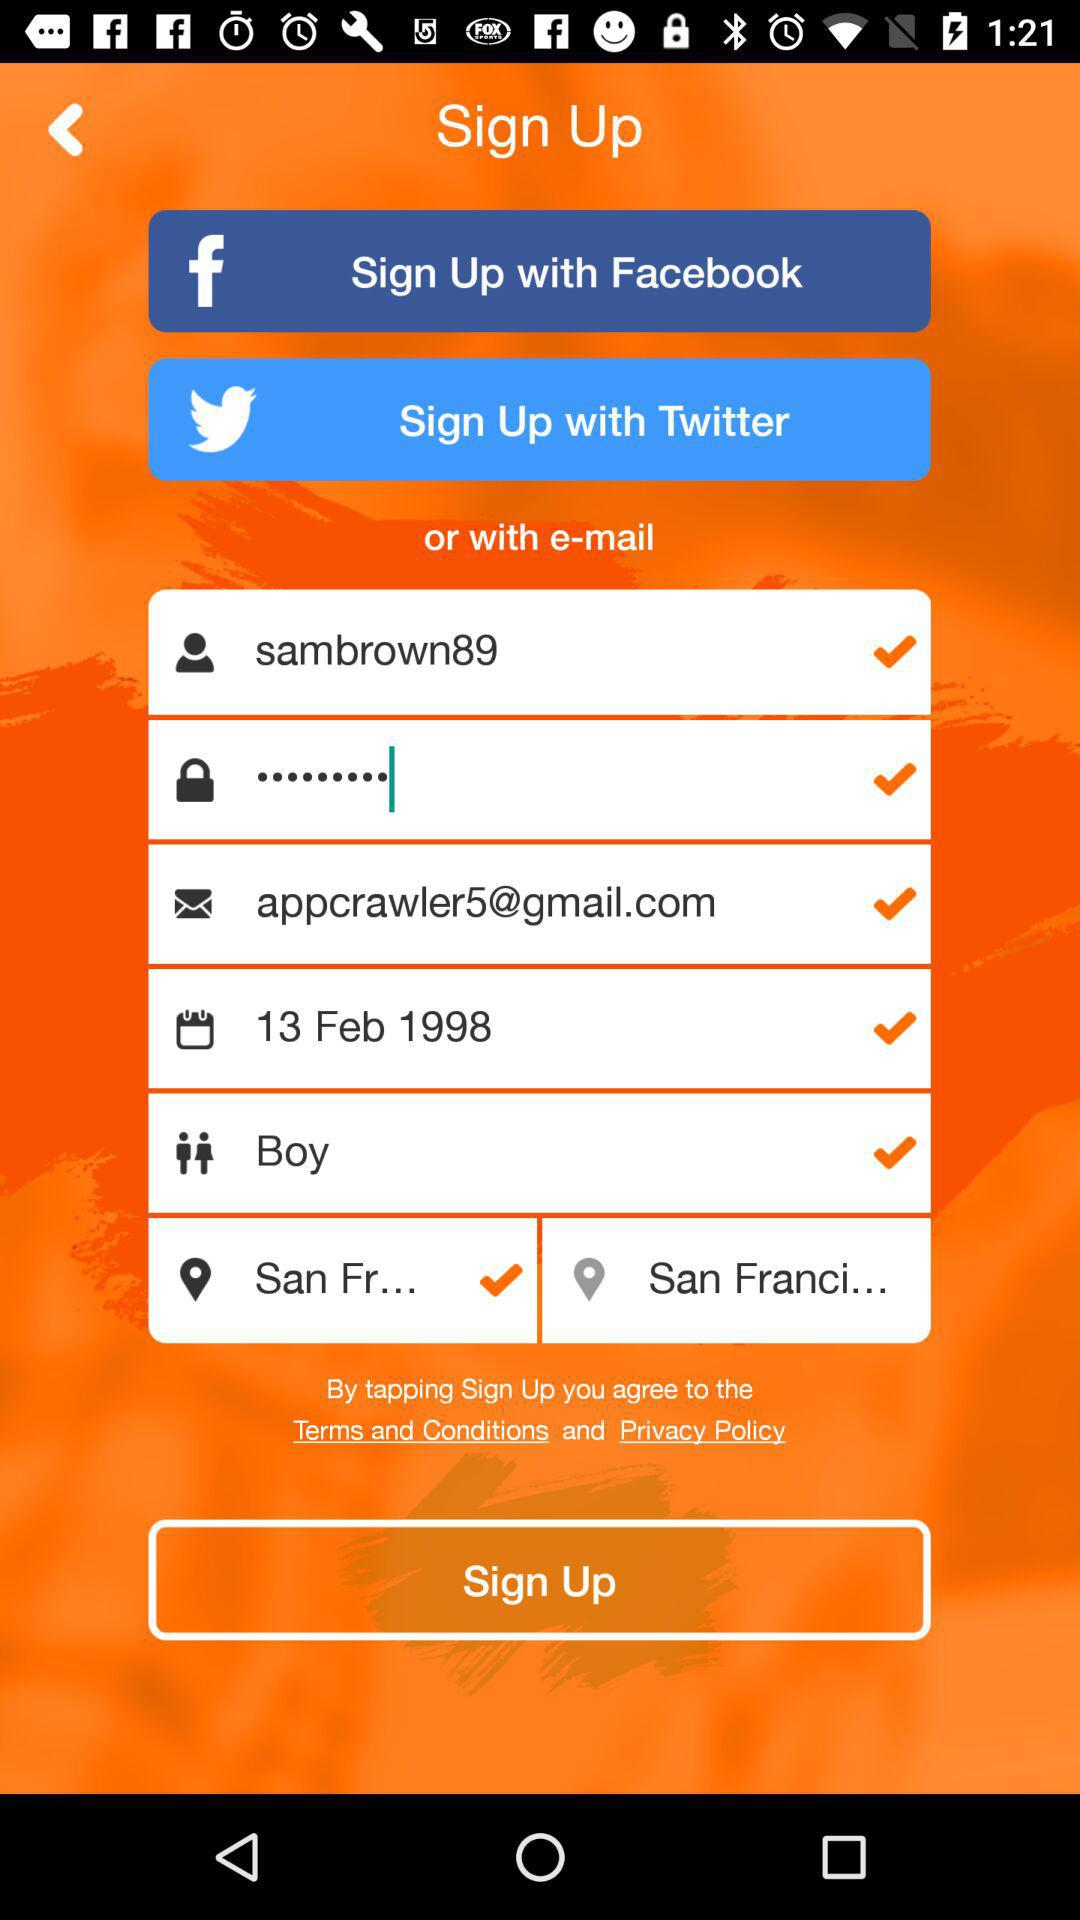What is the email address? The email address is appcrawler5@gmail.com. 